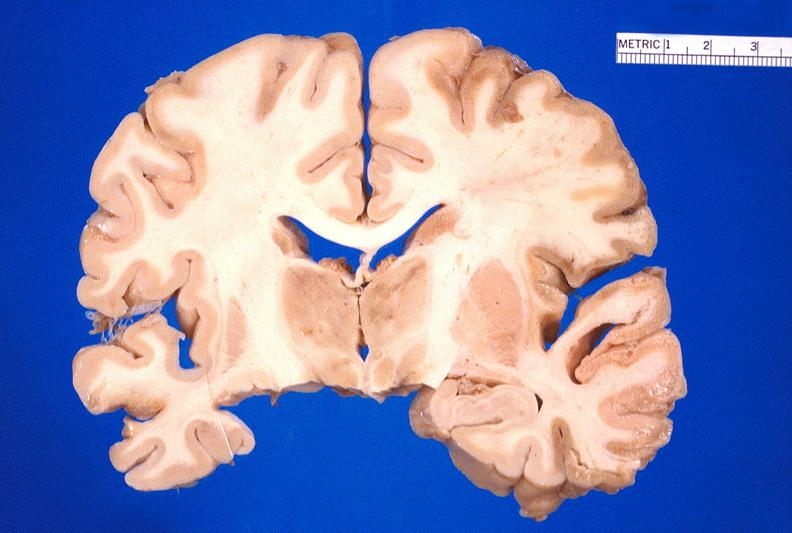what does this image show?
Answer the question using a single word or phrase. Brain 